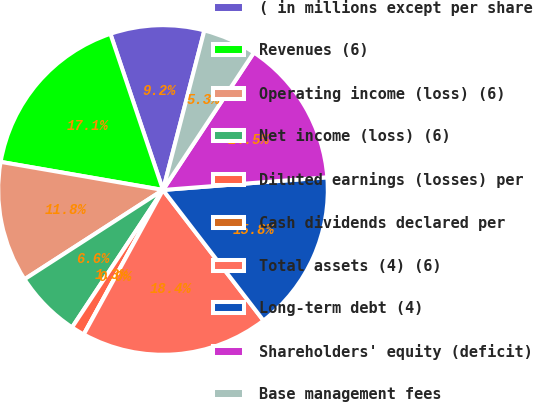Convert chart. <chart><loc_0><loc_0><loc_500><loc_500><pie_chart><fcel>( in millions except per share<fcel>Revenues (6)<fcel>Operating income (loss) (6)<fcel>Net income (loss) (6)<fcel>Diluted earnings (losses) per<fcel>Cash dividends declared per<fcel>Total assets (4) (6)<fcel>Long-term debt (4)<fcel>Shareholders' equity (deficit)<fcel>Base management fees<nl><fcel>9.21%<fcel>17.1%<fcel>11.84%<fcel>6.58%<fcel>1.32%<fcel>0.0%<fcel>18.42%<fcel>15.79%<fcel>14.47%<fcel>5.26%<nl></chart> 